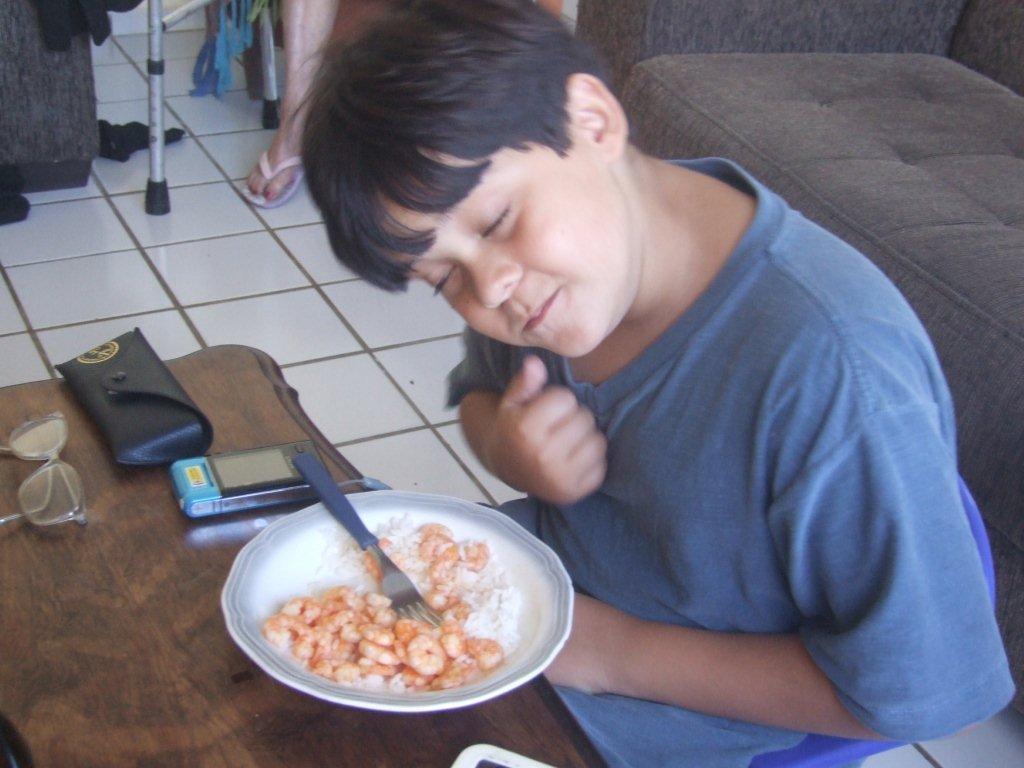Can you describe this image briefly? In this image we can see a man sitting on the chair and a table is placed in front of him. On the table there are pouch, spectacles, camera and a plate with come food and fork. In the background we can see person legs, floor, cloths and a sofa. 